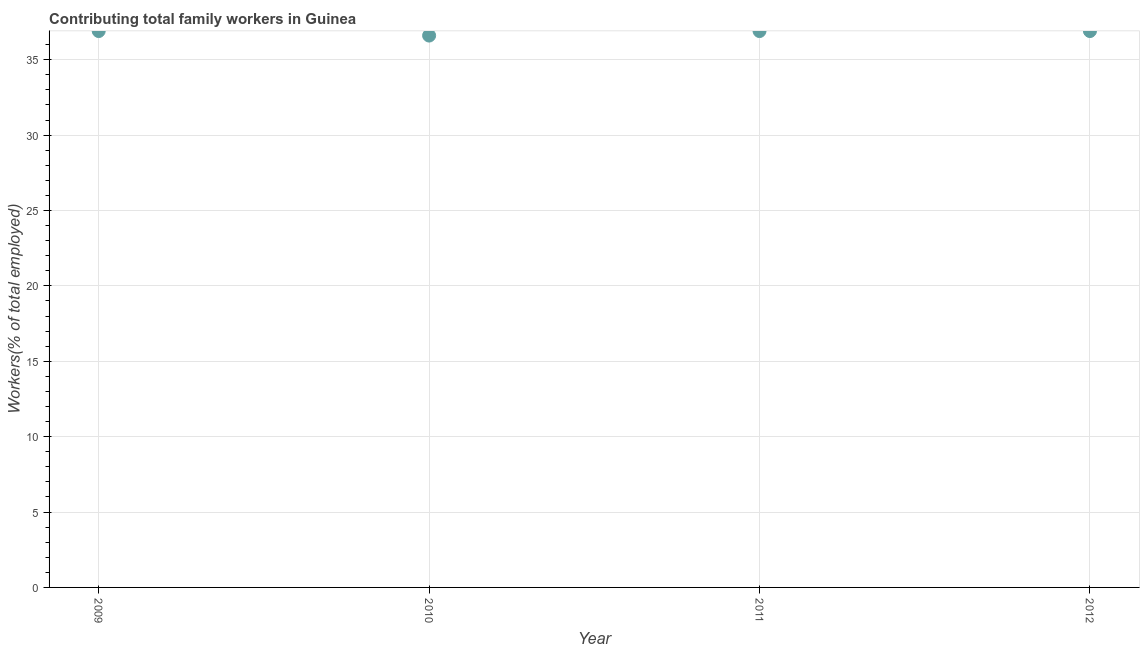What is the contributing family workers in 2011?
Provide a succinct answer. 36.9. Across all years, what is the maximum contributing family workers?
Make the answer very short. 36.9. Across all years, what is the minimum contributing family workers?
Offer a terse response. 36.6. In which year was the contributing family workers maximum?
Offer a very short reply. 2009. What is the sum of the contributing family workers?
Offer a terse response. 147.3. What is the difference between the contributing family workers in 2009 and 2010?
Provide a succinct answer. 0.3. What is the average contributing family workers per year?
Your response must be concise. 36.83. What is the median contributing family workers?
Provide a short and direct response. 36.9. In how many years, is the contributing family workers greater than 28 %?
Offer a terse response. 4. What is the ratio of the contributing family workers in 2010 to that in 2011?
Give a very brief answer. 0.99. Is the difference between the contributing family workers in 2009 and 2011 greater than the difference between any two years?
Provide a succinct answer. No. What is the difference between the highest and the second highest contributing family workers?
Make the answer very short. 0. What is the difference between the highest and the lowest contributing family workers?
Offer a very short reply. 0.3. In how many years, is the contributing family workers greater than the average contributing family workers taken over all years?
Provide a succinct answer. 3. Does the contributing family workers monotonically increase over the years?
Ensure brevity in your answer.  No. How many years are there in the graph?
Offer a very short reply. 4. What is the title of the graph?
Offer a very short reply. Contributing total family workers in Guinea. What is the label or title of the X-axis?
Keep it short and to the point. Year. What is the label or title of the Y-axis?
Provide a succinct answer. Workers(% of total employed). What is the Workers(% of total employed) in 2009?
Offer a very short reply. 36.9. What is the Workers(% of total employed) in 2010?
Offer a very short reply. 36.6. What is the Workers(% of total employed) in 2011?
Give a very brief answer. 36.9. What is the Workers(% of total employed) in 2012?
Provide a succinct answer. 36.9. What is the difference between the Workers(% of total employed) in 2009 and 2012?
Offer a terse response. 0. What is the difference between the Workers(% of total employed) in 2010 and 2012?
Keep it short and to the point. -0.3. What is the ratio of the Workers(% of total employed) in 2009 to that in 2010?
Keep it short and to the point. 1.01. What is the ratio of the Workers(% of total employed) in 2009 to that in 2011?
Offer a terse response. 1. What is the ratio of the Workers(% of total employed) in 2010 to that in 2012?
Give a very brief answer. 0.99. 